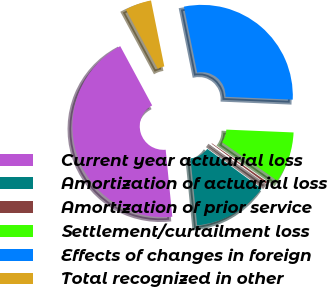Convert chart. <chart><loc_0><loc_0><loc_500><loc_500><pie_chart><fcel>Current year actuarial loss<fcel>Amortization of actuarial loss<fcel>Amortization of prior service<fcel>Settlement/curtailment loss<fcel>Effects of changes in foreign<fcel>Total recognized in other<nl><fcel>43.71%<fcel>13.37%<fcel>0.36%<fcel>9.03%<fcel>28.84%<fcel>4.7%<nl></chart> 